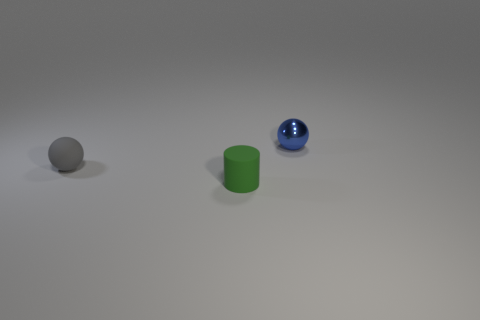Add 2 gray matte spheres. How many objects exist? 5 Subtract all balls. How many objects are left? 1 Add 2 cylinders. How many cylinders exist? 3 Subtract 0 purple blocks. How many objects are left? 3 Subtract all small yellow shiny objects. Subtract all small rubber cylinders. How many objects are left? 2 Add 3 small green matte cylinders. How many small green matte cylinders are left? 4 